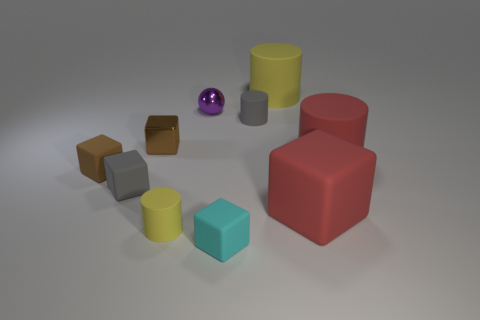There is a brown thing left of the metallic cube; what is its material?
Ensure brevity in your answer.  Rubber. There is another cube that is the same color as the metal block; what material is it?
Offer a terse response. Rubber. How many small things are either red cylinders or purple matte cubes?
Provide a succinct answer. 0. The metallic block has what color?
Make the answer very short. Brown. Is there a small shiny object that is to the right of the big red rubber cylinder in front of the metal cube?
Make the answer very short. No. Are there fewer large rubber cubes in front of the small yellow thing than tiny brown cubes?
Provide a succinct answer. Yes. Are the gray thing that is in front of the brown rubber block and the big yellow cylinder made of the same material?
Your answer should be compact. Yes. The other tiny cylinder that is the same material as the gray cylinder is what color?
Your response must be concise. Yellow. Are there fewer objects that are in front of the big red matte cylinder than objects right of the small gray block?
Your answer should be very brief. Yes. Is the color of the cylinder behind the tiny gray rubber cylinder the same as the small matte cylinder that is in front of the red block?
Give a very brief answer. Yes. 